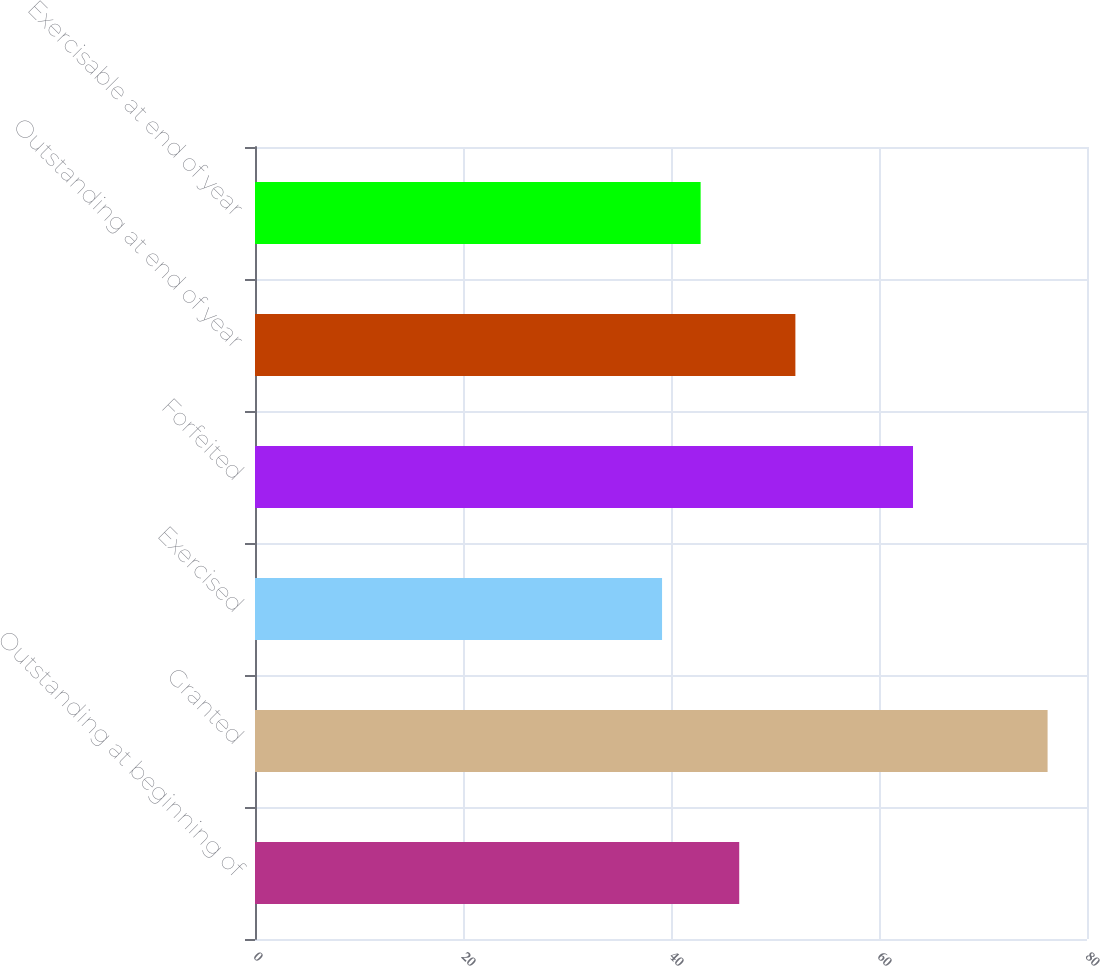Convert chart to OTSL. <chart><loc_0><loc_0><loc_500><loc_500><bar_chart><fcel>Outstanding at beginning of<fcel>Granted<fcel>Exercised<fcel>Forfeited<fcel>Outstanding at end of year<fcel>Exercisable at end of year<nl><fcel>46.56<fcel>76.21<fcel>39.14<fcel>63.27<fcel>51.96<fcel>42.85<nl></chart> 